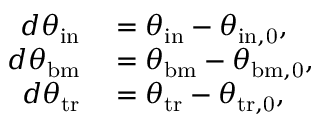Convert formula to latex. <formula><loc_0><loc_0><loc_500><loc_500>\begin{array} { r l } { d \theta _ { i n } } & = \theta _ { i n } - \theta _ { i n , 0 } , } \\ { d \theta _ { b m } } & = \theta _ { b m } - \theta _ { b m , 0 } , } \\ { d \theta _ { t r } } & = \theta _ { t r } - \theta _ { t r , 0 } , } \end{array}</formula> 